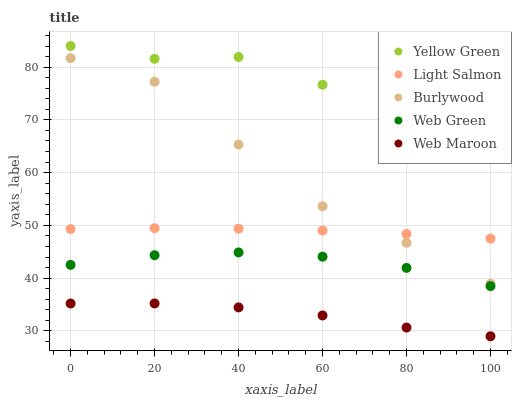Does Web Maroon have the minimum area under the curve?
Answer yes or no. Yes. Does Yellow Green have the maximum area under the curve?
Answer yes or no. Yes. Does Light Salmon have the minimum area under the curve?
Answer yes or no. No. Does Light Salmon have the maximum area under the curve?
Answer yes or no. No. Is Light Salmon the smoothest?
Answer yes or no. Yes. Is Yellow Green the roughest?
Answer yes or no. Yes. Is Web Maroon the smoothest?
Answer yes or no. No. Is Web Maroon the roughest?
Answer yes or no. No. Does Web Maroon have the lowest value?
Answer yes or no. Yes. Does Light Salmon have the lowest value?
Answer yes or no. No. Does Yellow Green have the highest value?
Answer yes or no. Yes. Does Light Salmon have the highest value?
Answer yes or no. No. Is Web Green less than Burlywood?
Answer yes or no. Yes. Is Yellow Green greater than Web Green?
Answer yes or no. Yes. Does Light Salmon intersect Burlywood?
Answer yes or no. Yes. Is Light Salmon less than Burlywood?
Answer yes or no. No. Is Light Salmon greater than Burlywood?
Answer yes or no. No. Does Web Green intersect Burlywood?
Answer yes or no. No. 